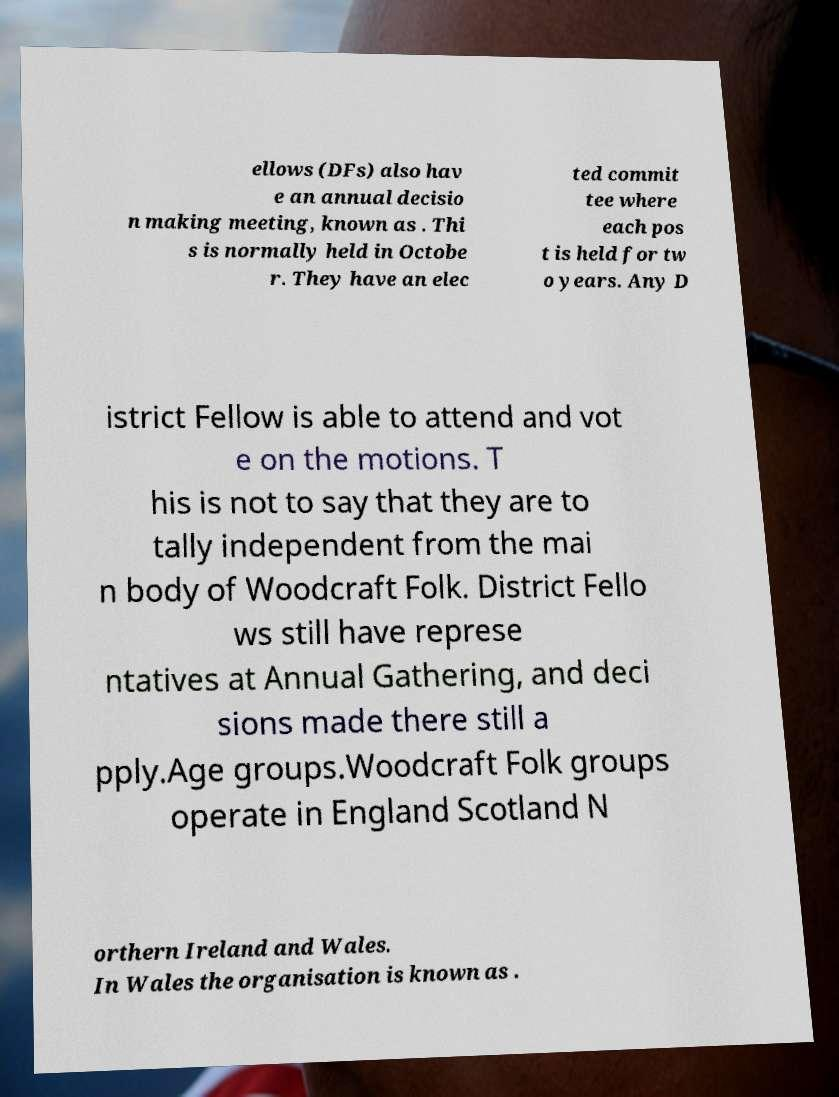Can you read and provide the text displayed in the image?This photo seems to have some interesting text. Can you extract and type it out for me? ellows (DFs) also hav e an annual decisio n making meeting, known as . Thi s is normally held in Octobe r. They have an elec ted commit tee where each pos t is held for tw o years. Any D istrict Fellow is able to attend and vot e on the motions. T his is not to say that they are to tally independent from the mai n body of Woodcraft Folk. District Fello ws still have represe ntatives at Annual Gathering, and deci sions made there still a pply.Age groups.Woodcraft Folk groups operate in England Scotland N orthern Ireland and Wales. In Wales the organisation is known as . 